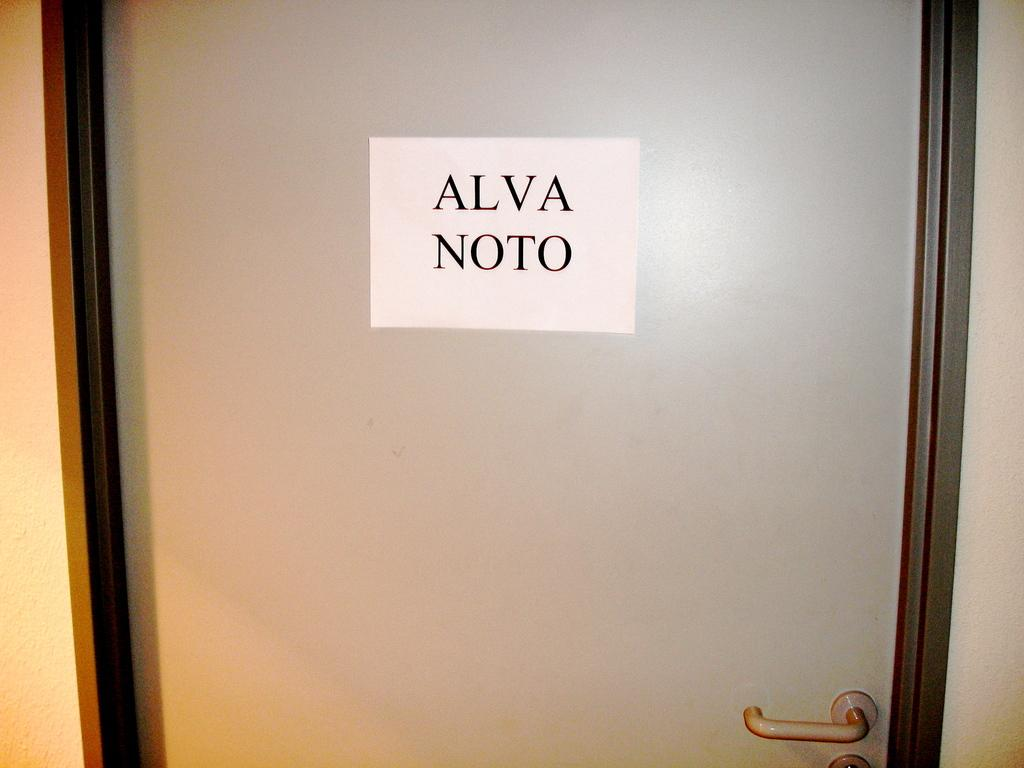What is present on the door in the image? There is a poster on the door. What is depicted on the poster? There is some text on the poster. What type of bread is being rated on the poster? There is no bread or rating system present on the poster; it only contains text. Can you see a tramp walking near the door in the image? There is no tramp or any person walking near the door in the image. 